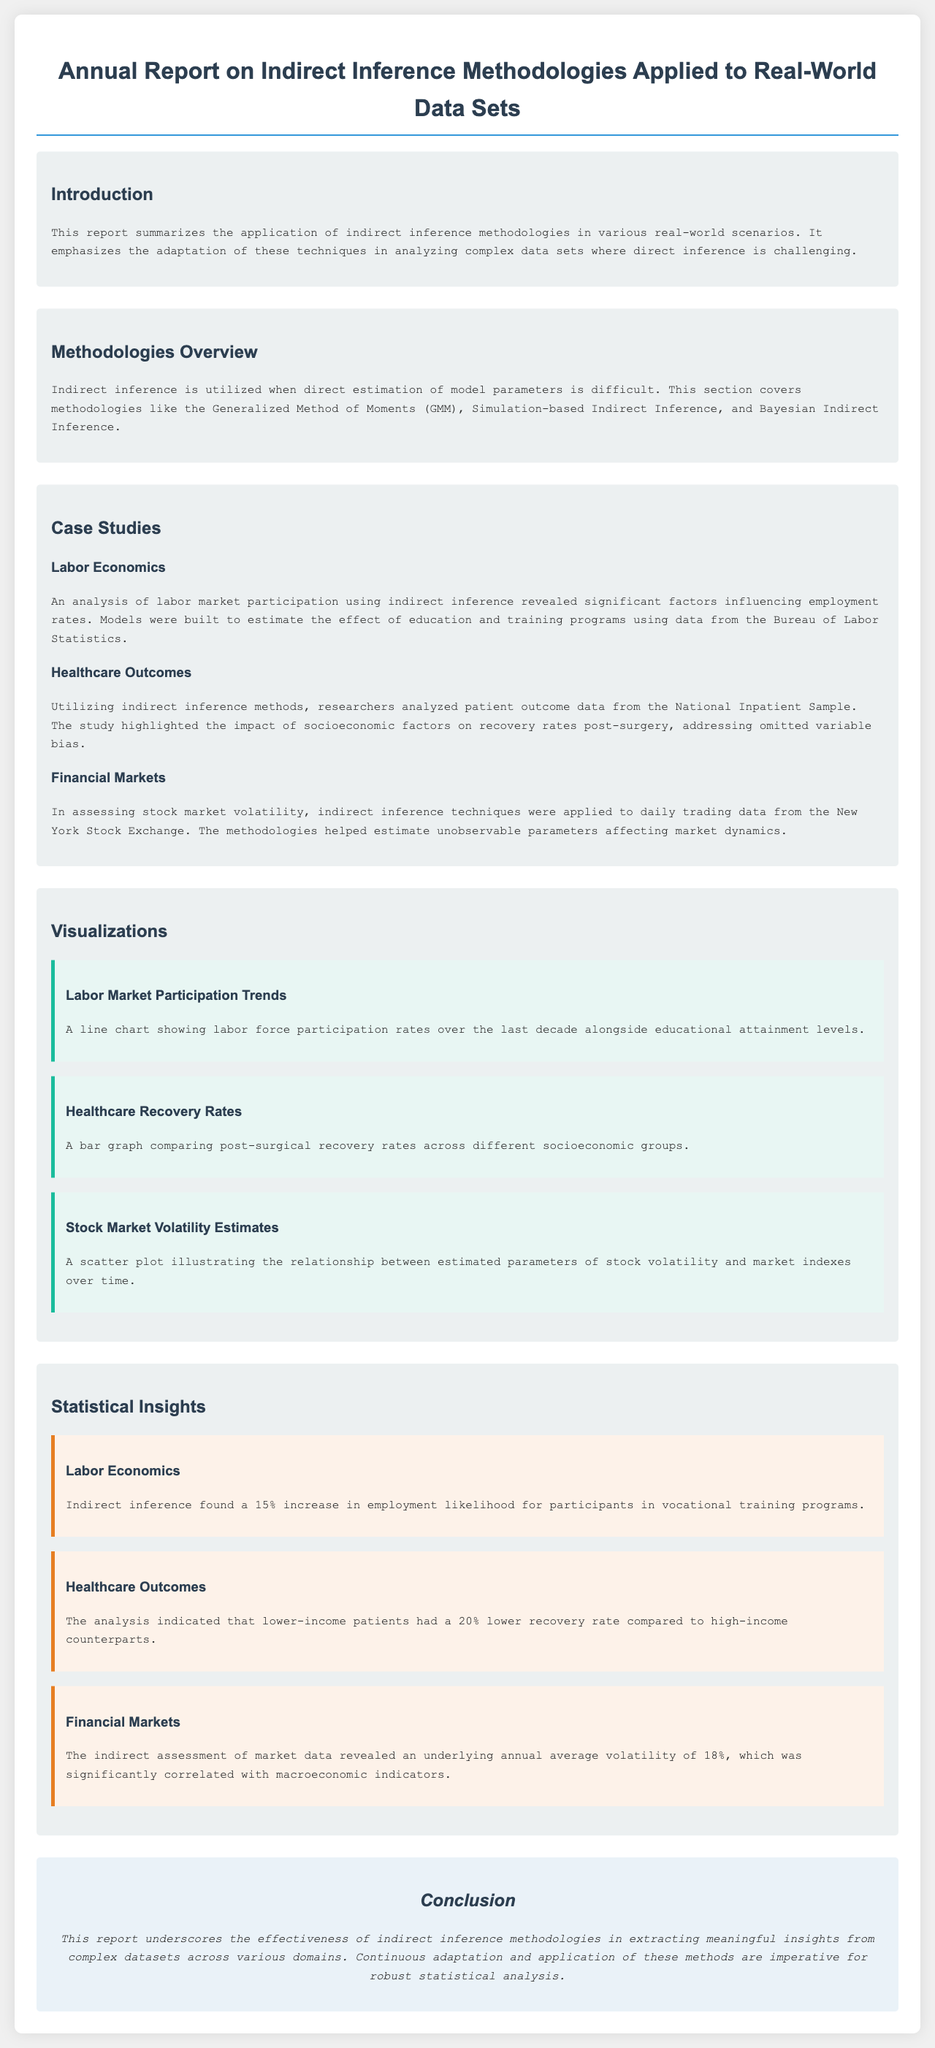What is the title of the report? The title of the report is presented in the heading of the document.
Answer: Annual Report on Indirect Inference Methodologies Applied to Real-World Data Sets What methodology is mentioned for analyzing labor economics? The methodology used in labor economics is specifically outlined in the case studies section.
Answer: Indirect inference What percentage increase in employment likelihood is reported for vocational training program participants? This statistic is provided in the statistical insights section focused on labor economics.
Answer: 15% What socioeconomic factor is highlighted in healthcare outcomes? The highlight regarding healthcare outcomes is detailed in the insights provided.
Answer: Socioeconomic factors What is the average annual volatility found in the financial markets analysis? The average annual volatility is summarized in the financial markets insight section.
Answer: 18% Which organization provided data for the analysis of labor market participation? The source of the data is noted in the case studies section related to labor economics.
Answer: Bureau of Labor Statistics What type of visualization is used for healthcare recovery rates? The visualization type is specified in the visualizations section discussing healthcare outcomes.
Answer: Bar graph What conclusion does the report emphasize regarding indirect inference methodologies? The concluding remarks summarize the main takeaway regarding the methodologies.
Answer: Effectiveness 